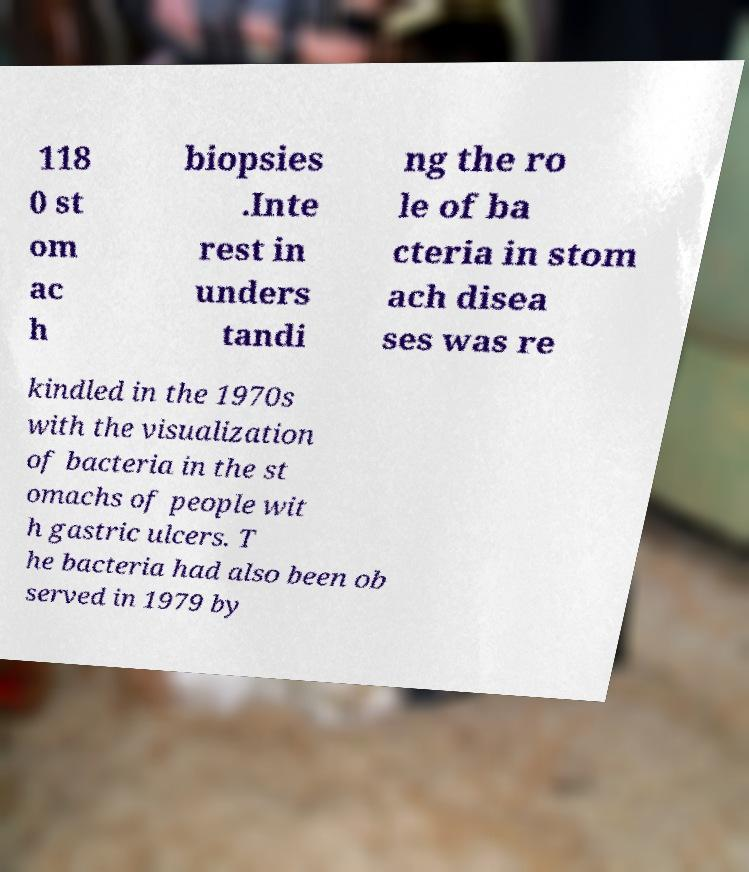Could you extract and type out the text from this image? 118 0 st om ac h biopsies .Inte rest in unders tandi ng the ro le of ba cteria in stom ach disea ses was re kindled in the 1970s with the visualization of bacteria in the st omachs of people wit h gastric ulcers. T he bacteria had also been ob served in 1979 by 